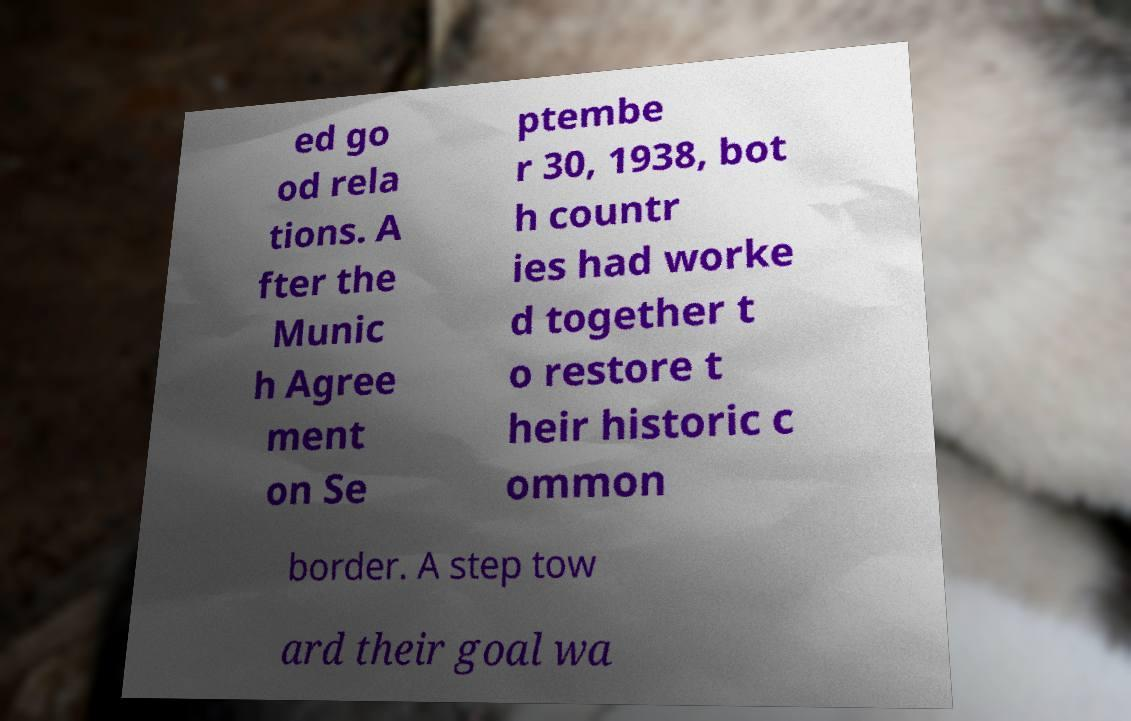Could you assist in decoding the text presented in this image and type it out clearly? ed go od rela tions. A fter the Munic h Agree ment on Se ptembe r 30, 1938, bot h countr ies had worke d together t o restore t heir historic c ommon border. A step tow ard their goal wa 